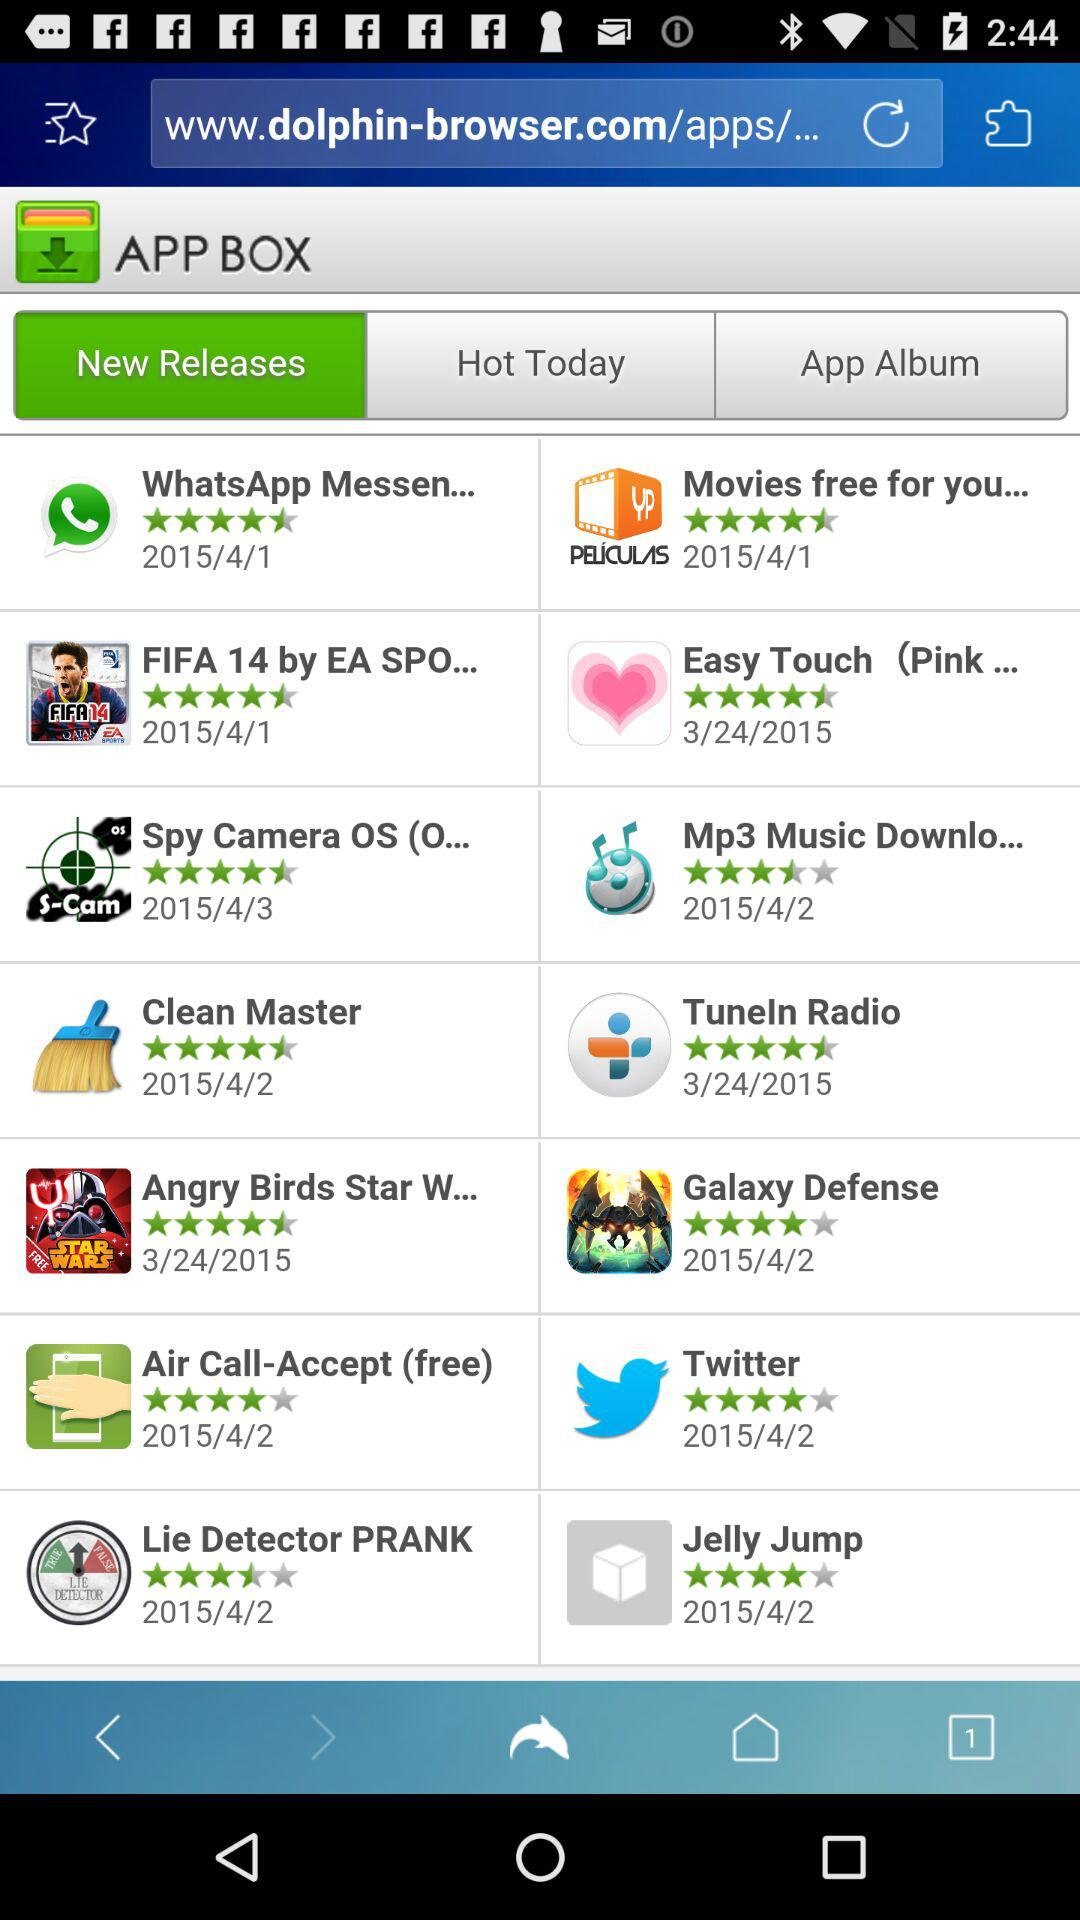What application is released on April 3, 2015? The application is "Spy Camera OS (O...". 